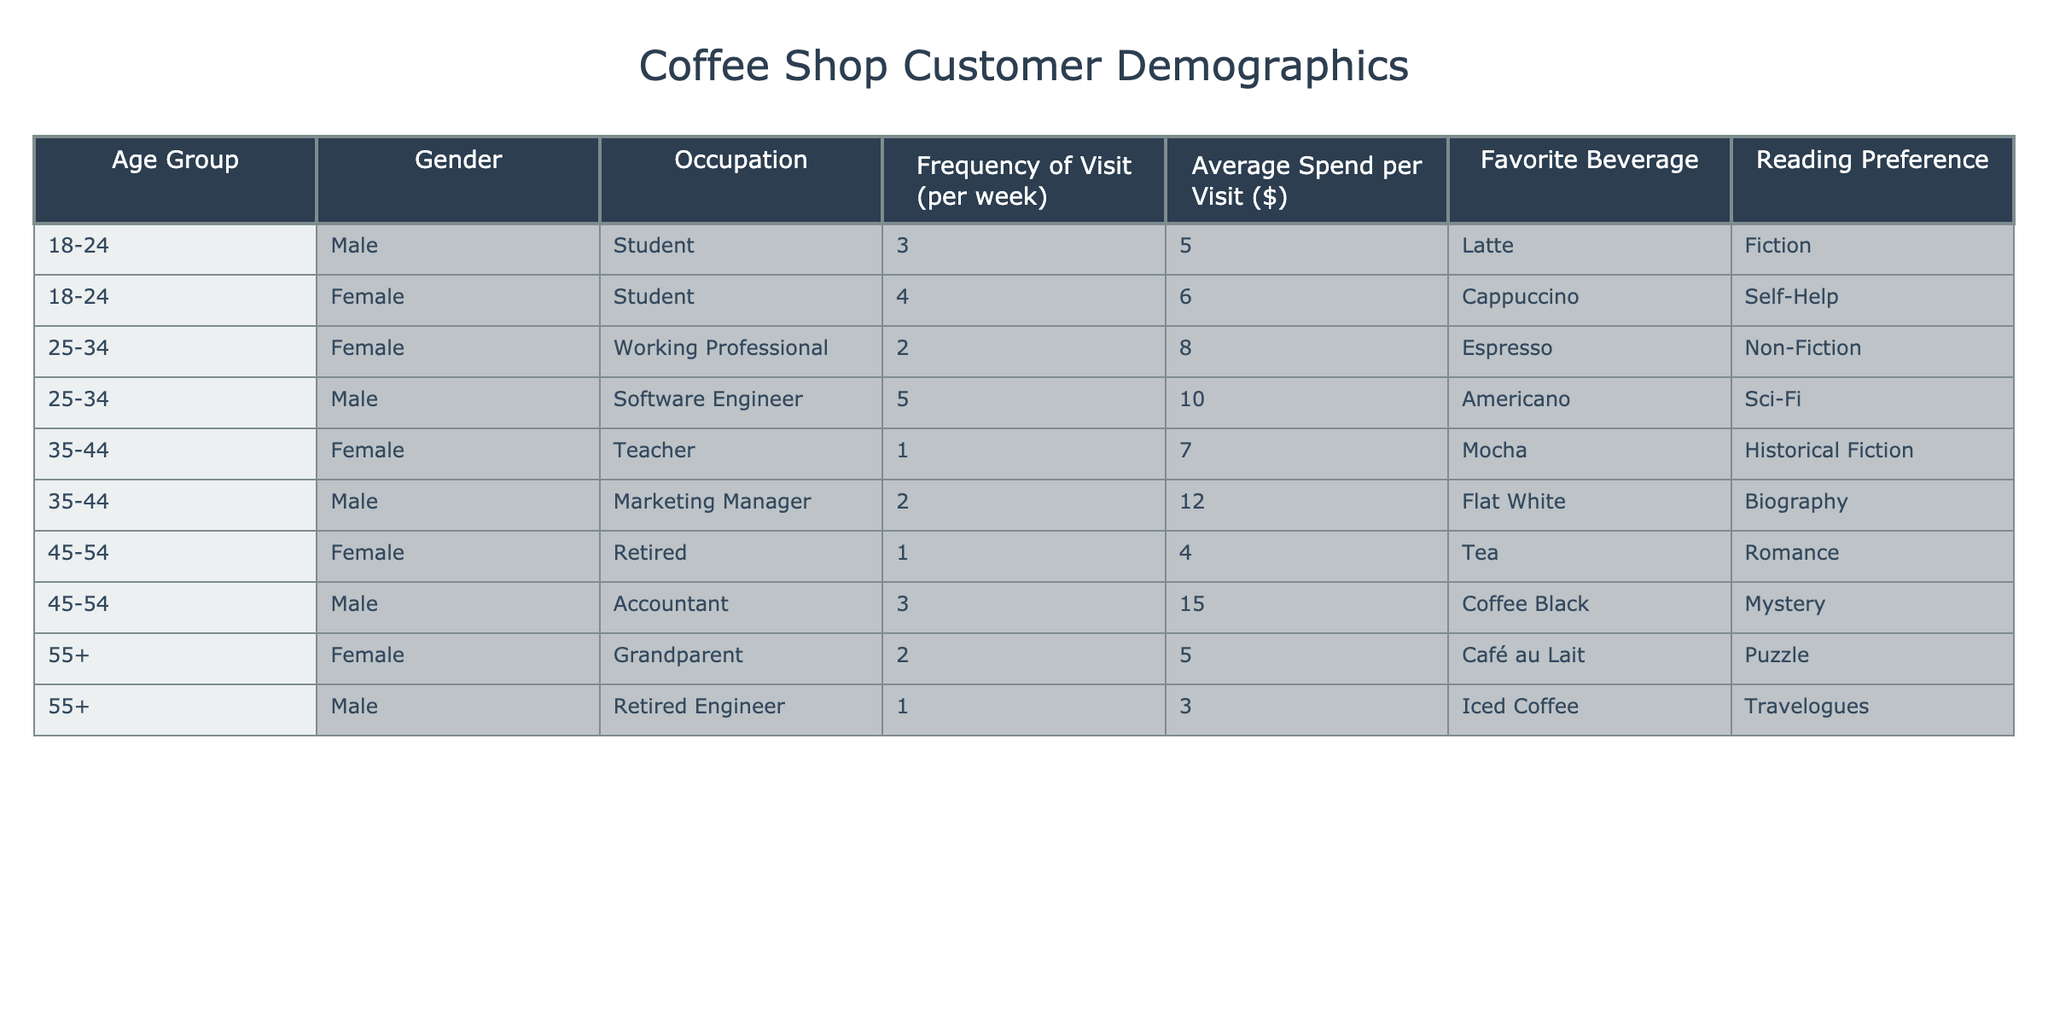What is the favorite beverage of the youngest age group? The youngest age group (18-24) includes two individuals: one male who prefers Latte and one female who prefers Cappuccino. Since it's asking for a favorite beverage, we can say that the options are Latte and Cappuccino.
Answer: Latte and Cappuccino How many female customers visit the coffee shop at least twice a week? Referring to the table, there are two females in the demographics who visit the shop at least twice a week: one female student visits 4 times and one female working professional visits 2 times.
Answer: 2 What is the average spend per visit for male customers? We identify the male customers: The male student spends 5, the male software engineer spends 10, the marketing manager spends 12, the male accountant spends 15, and the retired engineer spends 3. Summing these amounts gives 5 + 10 + 12 + 15 + 3 = 55. Since there are 5 male customers, the average spend is 55/5 = 11.
Answer: 11 Do any retired individuals in the data prefer the beverage 'Tea'? Looking at the table, the retired individual is a female in the 45-54 age group who prefers Tea. Hence, the statement is true.
Answer: Yes What is the combined frequency of visits per week for all customers aged 35-44? The customers in the 35-44 age group are one female teacher who visits once a week and one male marketing manager who visits twice a week. Combining these frequencies gives 1 + 2 = 3 visits per week.
Answer: 3 What is the favorite reading preference of the customer that visits the most frequently? The customer who visits the most frequently is the male software engineer in the age group 25-34, visiting 5 times a week. His favorite reading preference is Sci-Fi.
Answer: Sci-Fi How many customers aged 45-54 spend more than $10 per visit? The table shows one male account who spends 15 and one female retired individual who spends 4. Only the male accountant spends more than 10. Hence, there is one customer aged 45-54 who fits this criterion.
Answer: 1 What is the total frequency of visits for customers who prefer Non-Fiction as a reading preference? The only customer who prefers Non-Fiction is the female working professional aged 25-34, who visits 2 times a week. Hence, the total frequency of visits for Non-Fiction preference is 2.
Answer: 2 